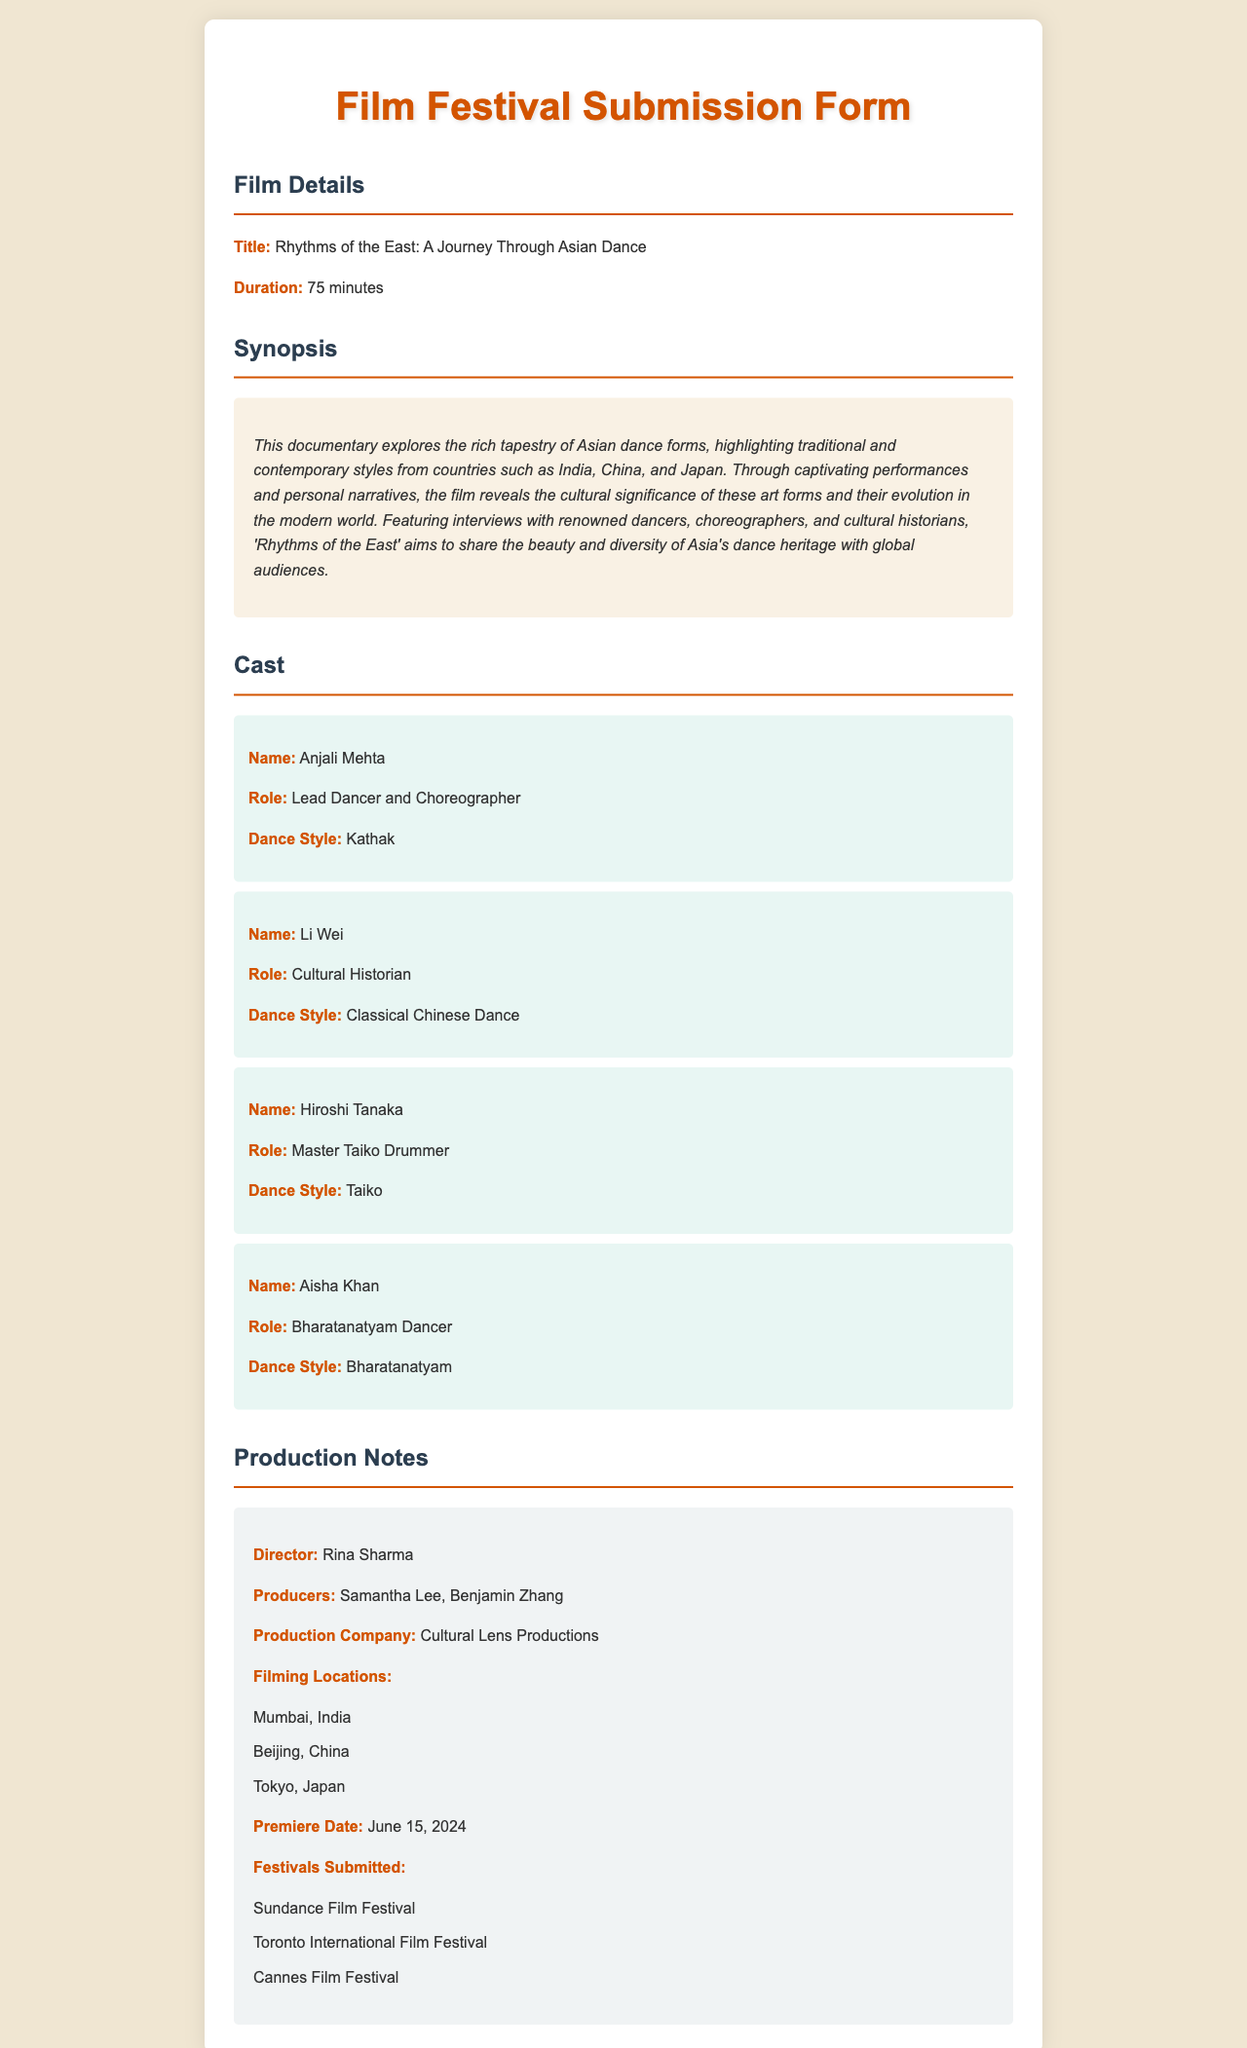What is the title of the documentary? The title is explicitly stated in the document under the Film Details section.
Answer: Rhythms of the East: A Journey Through Asian Dance What is the duration of the film? The duration is mentioned directly in the Film Details section.
Answer: 75 minutes Who is the lead dancer and choreographer? The document provides this information in the Cast section.
Answer: Anjali Mehta Which dance style does Hiroshi Tanaka perform? This information is found under the cast member details for Hiroshi Tanaka.
Answer: Taiko What is the premiere date of the film? The premiere date is clearly listed under the Production Notes section.
Answer: June 15, 2024 Which production company is behind the film? This detail is found in the Production Notes section of the document.
Answer: Cultural Lens Productions What are the filming locations mentioned in the document? This question requires extracting multiple pieces of information from the Production Notes section.
Answer: Mumbai, India; Beijing, China; Tokyo, Japan What is the purpose of the documentary as described? The purpose is outlined in the synopsis and relates to sharing cultural heritage.
Answer: Share the beauty and diversity of Asia's dance heritage Which film festivals has the documentary been submitted to? The document lists several festivals in the Production Notes section.
Answer: Sundance Film Festival; Toronto International Film Festival; Cannes Film Festival 